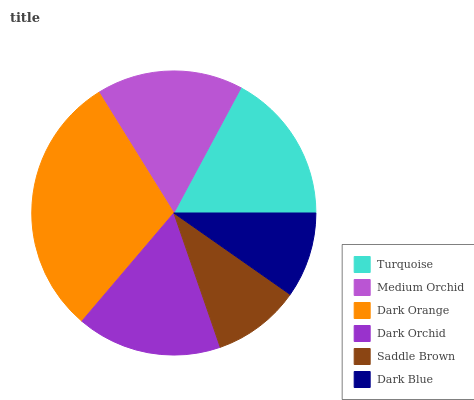Is Dark Blue the minimum?
Answer yes or no. Yes. Is Dark Orange the maximum?
Answer yes or no. Yes. Is Medium Orchid the minimum?
Answer yes or no. No. Is Medium Orchid the maximum?
Answer yes or no. No. Is Turquoise greater than Medium Orchid?
Answer yes or no. Yes. Is Medium Orchid less than Turquoise?
Answer yes or no. Yes. Is Medium Orchid greater than Turquoise?
Answer yes or no. No. Is Turquoise less than Medium Orchid?
Answer yes or no. No. Is Medium Orchid the high median?
Answer yes or no. Yes. Is Dark Orchid the low median?
Answer yes or no. Yes. Is Dark Orange the high median?
Answer yes or no. No. Is Turquoise the low median?
Answer yes or no. No. 